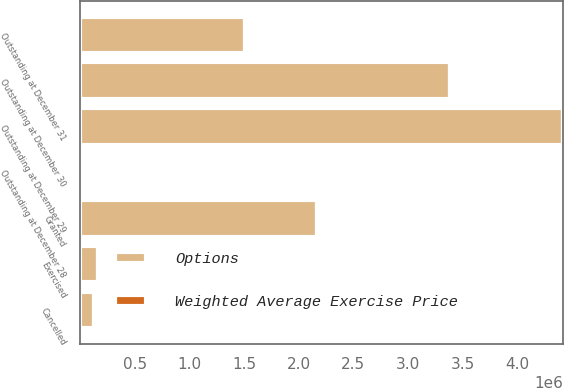Convert chart to OTSL. <chart><loc_0><loc_0><loc_500><loc_500><stacked_bar_chart><ecel><fcel>Outstanding at December 31<fcel>Granted<fcel>Exercised<fcel>Cancelled<fcel>Outstanding at December 30<fcel>Outstanding at December 29<fcel>Outstanding at December 28<nl><fcel>Options<fcel>1.5074e+06<fcel>2.1661e+06<fcel>163523<fcel>129177<fcel>3.3808e+06<fcel>4.42278e+06<fcel>11.26<nl><fcel>Weighted Average Exercise Price<fcel>8.57<fcel>8.78<fcel>0.84<fcel>11.26<fcel>8.97<fcel>7.94<fcel>6.95<nl></chart> 